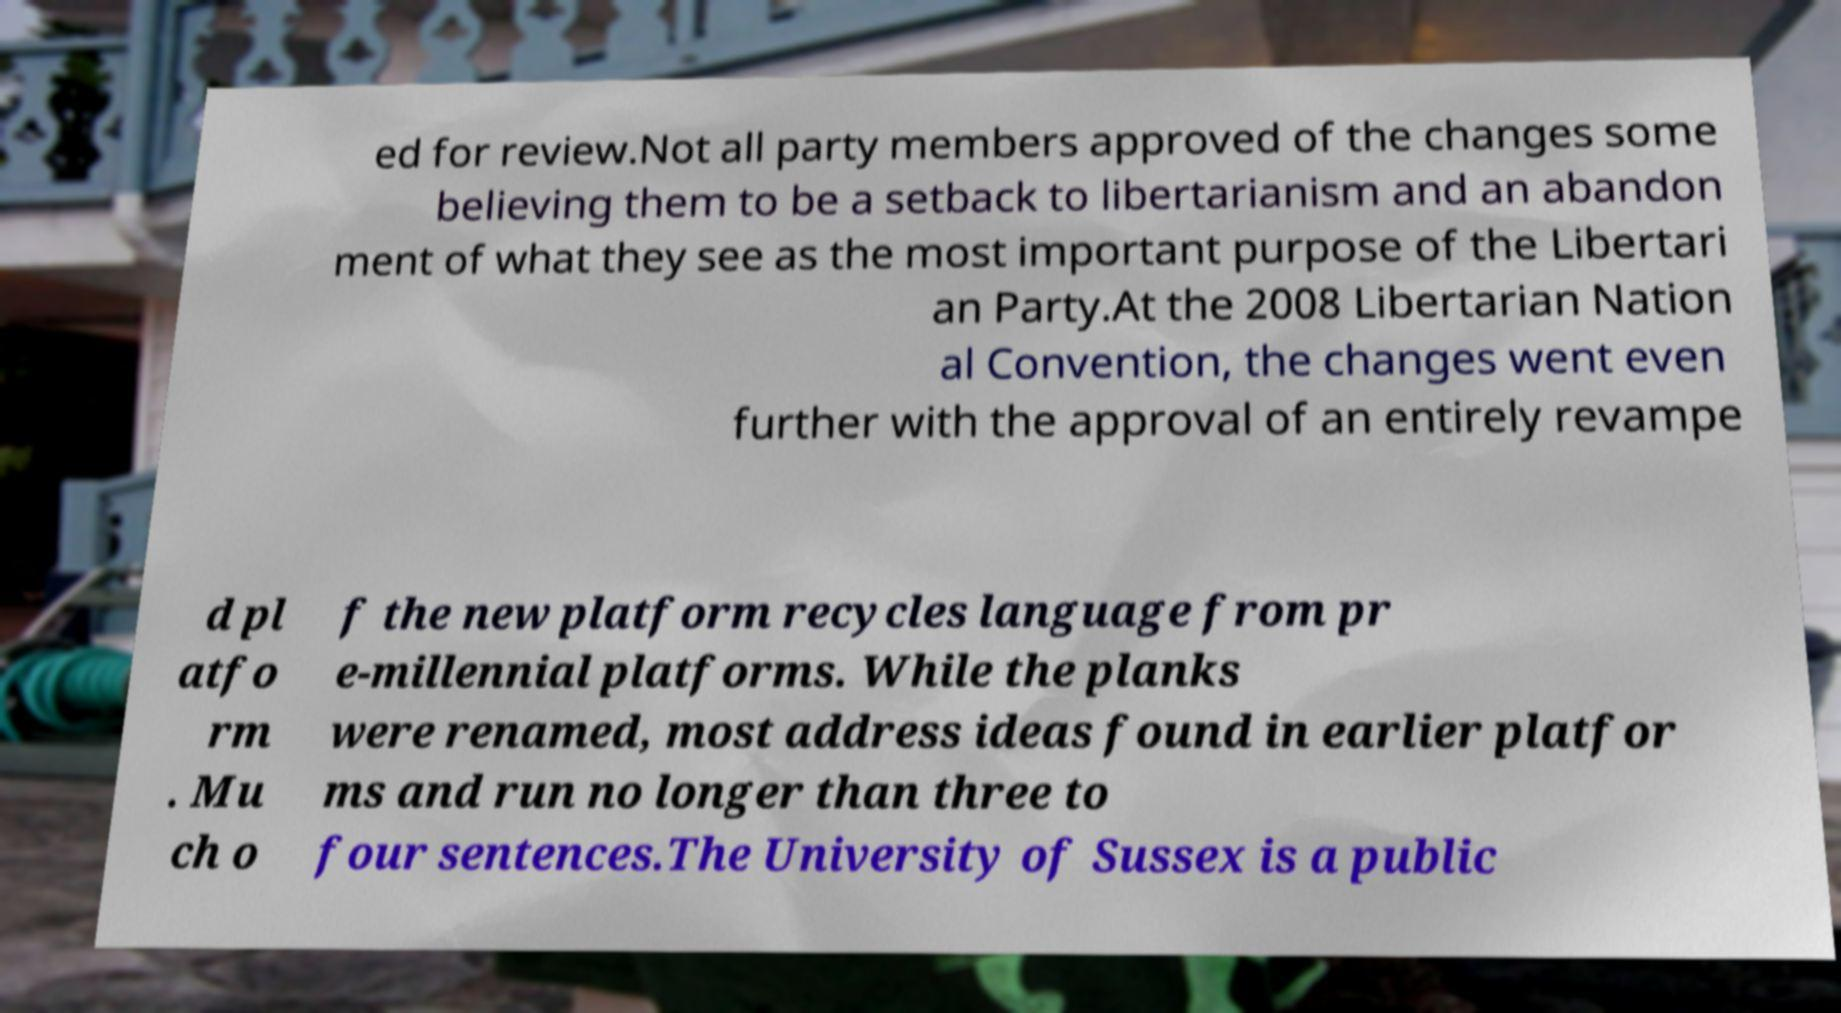Could you extract and type out the text from this image? ed for review.Not all party members approved of the changes some believing them to be a setback to libertarianism and an abandon ment of what they see as the most important purpose of the Libertari an Party.At the 2008 Libertarian Nation al Convention, the changes went even further with the approval of an entirely revampe d pl atfo rm . Mu ch o f the new platform recycles language from pr e-millennial platforms. While the planks were renamed, most address ideas found in earlier platfor ms and run no longer than three to four sentences.The University of Sussex is a public 